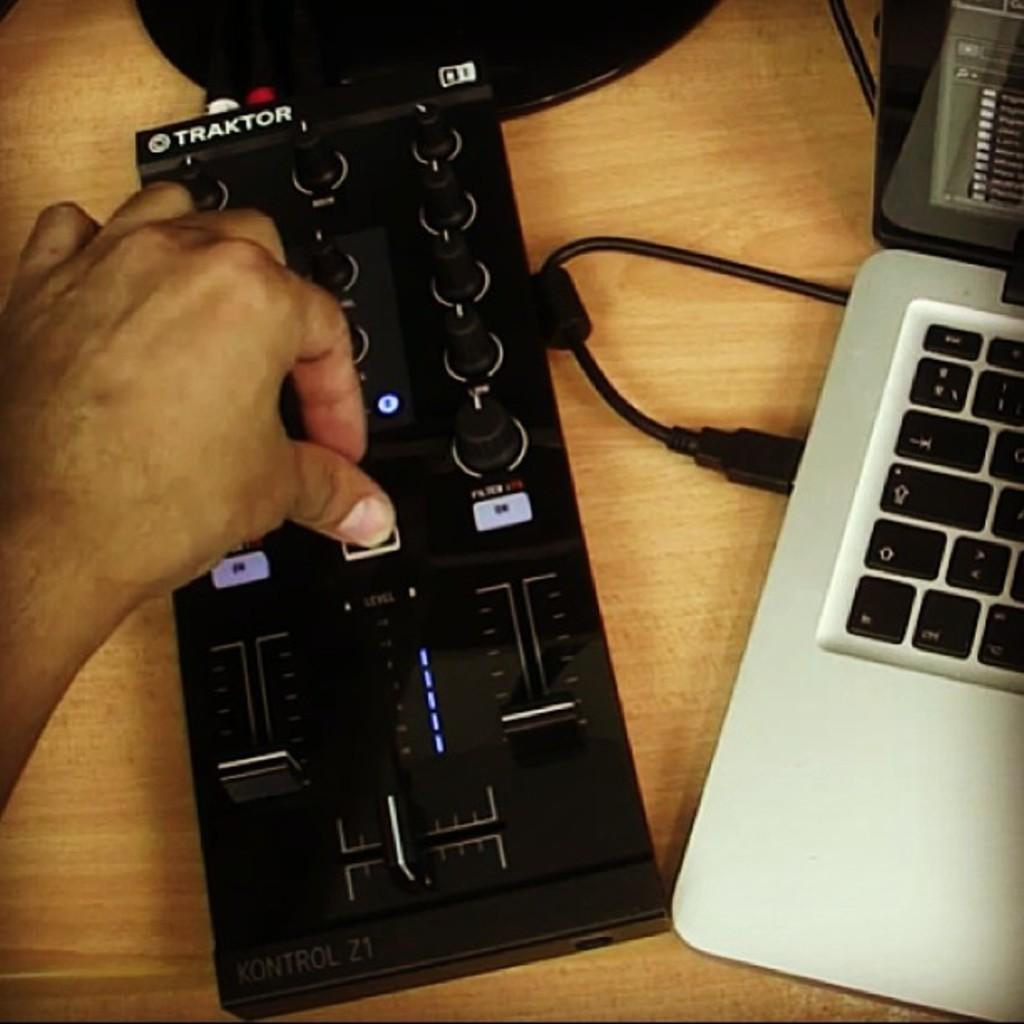Provide a one-sentence caption for the provided image. A person is hitting a remote control button and the remote says TRAKTOR on it. 